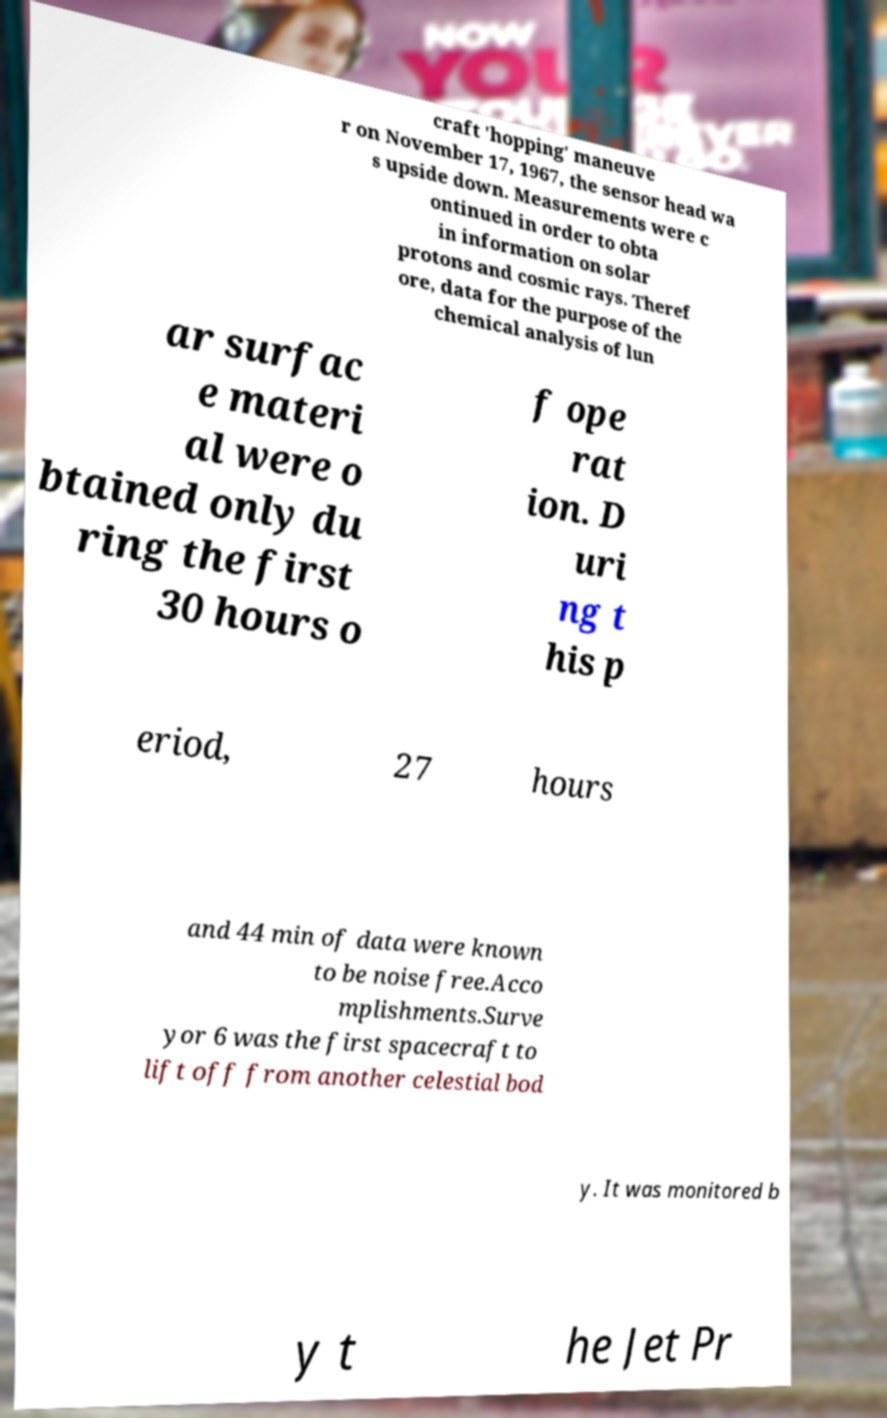Could you assist in decoding the text presented in this image and type it out clearly? craft 'hopping' maneuve r on November 17, 1967, the sensor head wa s upside down. Measurements were c ontinued in order to obta in information on solar protons and cosmic rays. Theref ore, data for the purpose of the chemical analysis of lun ar surfac e materi al were o btained only du ring the first 30 hours o f ope rat ion. D uri ng t his p eriod, 27 hours and 44 min of data were known to be noise free.Acco mplishments.Surve yor 6 was the first spacecraft to lift off from another celestial bod y. It was monitored b y t he Jet Pr 